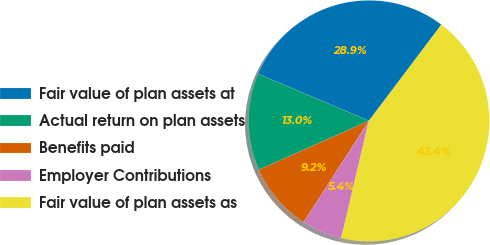<chart> <loc_0><loc_0><loc_500><loc_500><pie_chart><fcel>Fair value of plan assets at<fcel>Actual return on plan assets<fcel>Benefits paid<fcel>Employer Contributions<fcel>Fair value of plan assets as<nl><fcel>28.91%<fcel>13.02%<fcel>9.22%<fcel>5.42%<fcel>43.42%<nl></chart> 